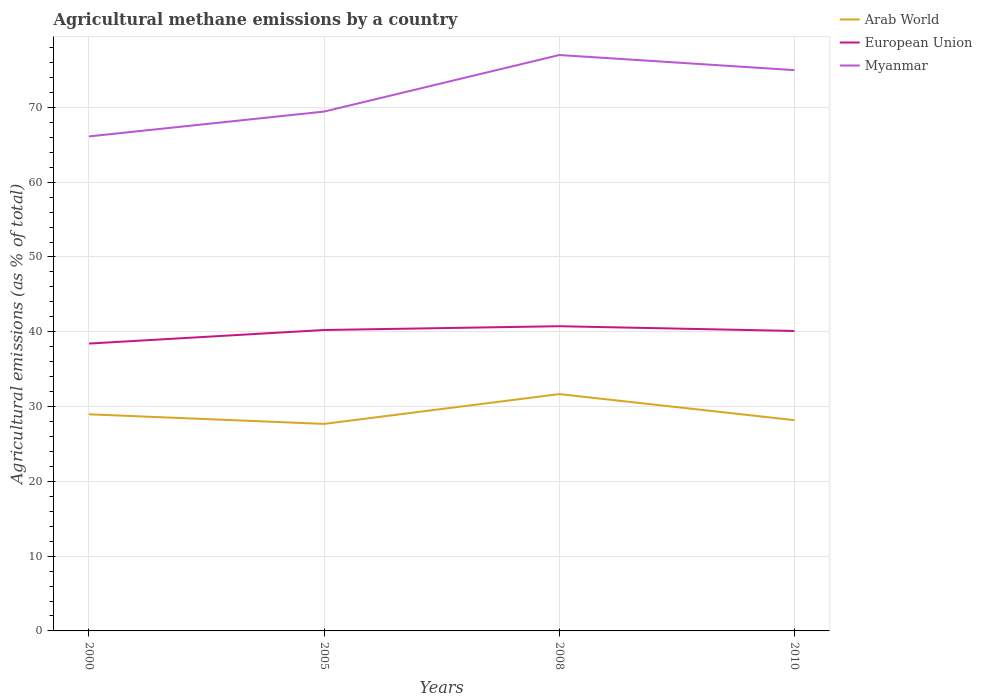How many different coloured lines are there?
Provide a succinct answer. 3. Is the number of lines equal to the number of legend labels?
Your answer should be compact. Yes. Across all years, what is the maximum amount of agricultural methane emitted in Myanmar?
Your response must be concise. 66.12. In which year was the amount of agricultural methane emitted in European Union maximum?
Offer a very short reply. 2000. What is the total amount of agricultural methane emitted in European Union in the graph?
Your response must be concise. -0.51. What is the difference between the highest and the second highest amount of agricultural methane emitted in Arab World?
Provide a short and direct response. 3.99. What is the difference between the highest and the lowest amount of agricultural methane emitted in Arab World?
Your answer should be very brief. 1. What is the difference between two consecutive major ticks on the Y-axis?
Your answer should be compact. 10. Does the graph contain grids?
Offer a very short reply. Yes. How are the legend labels stacked?
Offer a terse response. Vertical. What is the title of the graph?
Provide a succinct answer. Agricultural methane emissions by a country. What is the label or title of the Y-axis?
Ensure brevity in your answer.  Agricultural emissions (as % of total). What is the Agricultural emissions (as % of total) of Arab World in 2000?
Make the answer very short. 28.96. What is the Agricultural emissions (as % of total) in European Union in 2000?
Keep it short and to the point. 38.42. What is the Agricultural emissions (as % of total) of Myanmar in 2000?
Your answer should be compact. 66.12. What is the Agricultural emissions (as % of total) in Arab World in 2005?
Offer a very short reply. 27.68. What is the Agricultural emissions (as % of total) of European Union in 2005?
Keep it short and to the point. 40.24. What is the Agricultural emissions (as % of total) in Myanmar in 2005?
Offer a very short reply. 69.44. What is the Agricultural emissions (as % of total) in Arab World in 2008?
Offer a very short reply. 31.67. What is the Agricultural emissions (as % of total) of European Union in 2008?
Offer a terse response. 40.74. What is the Agricultural emissions (as % of total) in Myanmar in 2008?
Give a very brief answer. 77. What is the Agricultural emissions (as % of total) of Arab World in 2010?
Offer a terse response. 28.18. What is the Agricultural emissions (as % of total) of European Union in 2010?
Your response must be concise. 40.11. What is the Agricultural emissions (as % of total) in Myanmar in 2010?
Provide a succinct answer. 74.98. Across all years, what is the maximum Agricultural emissions (as % of total) of Arab World?
Provide a short and direct response. 31.67. Across all years, what is the maximum Agricultural emissions (as % of total) in European Union?
Give a very brief answer. 40.74. Across all years, what is the maximum Agricultural emissions (as % of total) of Myanmar?
Offer a very short reply. 77. Across all years, what is the minimum Agricultural emissions (as % of total) in Arab World?
Your response must be concise. 27.68. Across all years, what is the minimum Agricultural emissions (as % of total) of European Union?
Ensure brevity in your answer.  38.42. Across all years, what is the minimum Agricultural emissions (as % of total) of Myanmar?
Keep it short and to the point. 66.12. What is the total Agricultural emissions (as % of total) in Arab World in the graph?
Keep it short and to the point. 116.49. What is the total Agricultural emissions (as % of total) in European Union in the graph?
Your answer should be compact. 159.5. What is the total Agricultural emissions (as % of total) in Myanmar in the graph?
Your response must be concise. 287.54. What is the difference between the Agricultural emissions (as % of total) of Arab World in 2000 and that in 2005?
Give a very brief answer. 1.28. What is the difference between the Agricultural emissions (as % of total) of European Union in 2000 and that in 2005?
Offer a very short reply. -1.81. What is the difference between the Agricultural emissions (as % of total) in Myanmar in 2000 and that in 2005?
Your answer should be very brief. -3.32. What is the difference between the Agricultural emissions (as % of total) in Arab World in 2000 and that in 2008?
Your answer should be compact. -2.7. What is the difference between the Agricultural emissions (as % of total) in European Union in 2000 and that in 2008?
Make the answer very short. -2.32. What is the difference between the Agricultural emissions (as % of total) in Myanmar in 2000 and that in 2008?
Your answer should be very brief. -10.88. What is the difference between the Agricultural emissions (as % of total) of Arab World in 2000 and that in 2010?
Offer a terse response. 0.79. What is the difference between the Agricultural emissions (as % of total) of European Union in 2000 and that in 2010?
Keep it short and to the point. -1.68. What is the difference between the Agricultural emissions (as % of total) in Myanmar in 2000 and that in 2010?
Your answer should be very brief. -8.86. What is the difference between the Agricultural emissions (as % of total) of Arab World in 2005 and that in 2008?
Provide a short and direct response. -3.99. What is the difference between the Agricultural emissions (as % of total) in European Union in 2005 and that in 2008?
Ensure brevity in your answer.  -0.51. What is the difference between the Agricultural emissions (as % of total) in Myanmar in 2005 and that in 2008?
Provide a succinct answer. -7.56. What is the difference between the Agricultural emissions (as % of total) of Arab World in 2005 and that in 2010?
Give a very brief answer. -0.5. What is the difference between the Agricultural emissions (as % of total) in European Union in 2005 and that in 2010?
Your response must be concise. 0.13. What is the difference between the Agricultural emissions (as % of total) in Myanmar in 2005 and that in 2010?
Ensure brevity in your answer.  -5.54. What is the difference between the Agricultural emissions (as % of total) in Arab World in 2008 and that in 2010?
Ensure brevity in your answer.  3.49. What is the difference between the Agricultural emissions (as % of total) in European Union in 2008 and that in 2010?
Your answer should be very brief. 0.64. What is the difference between the Agricultural emissions (as % of total) in Myanmar in 2008 and that in 2010?
Ensure brevity in your answer.  2.02. What is the difference between the Agricultural emissions (as % of total) of Arab World in 2000 and the Agricultural emissions (as % of total) of European Union in 2005?
Provide a succinct answer. -11.27. What is the difference between the Agricultural emissions (as % of total) in Arab World in 2000 and the Agricultural emissions (as % of total) in Myanmar in 2005?
Provide a succinct answer. -40.48. What is the difference between the Agricultural emissions (as % of total) of European Union in 2000 and the Agricultural emissions (as % of total) of Myanmar in 2005?
Offer a very short reply. -31.02. What is the difference between the Agricultural emissions (as % of total) of Arab World in 2000 and the Agricultural emissions (as % of total) of European Union in 2008?
Give a very brief answer. -11.78. What is the difference between the Agricultural emissions (as % of total) in Arab World in 2000 and the Agricultural emissions (as % of total) in Myanmar in 2008?
Give a very brief answer. -48.04. What is the difference between the Agricultural emissions (as % of total) in European Union in 2000 and the Agricultural emissions (as % of total) in Myanmar in 2008?
Offer a terse response. -38.58. What is the difference between the Agricultural emissions (as % of total) in Arab World in 2000 and the Agricultural emissions (as % of total) in European Union in 2010?
Give a very brief answer. -11.14. What is the difference between the Agricultural emissions (as % of total) in Arab World in 2000 and the Agricultural emissions (as % of total) in Myanmar in 2010?
Keep it short and to the point. -46.02. What is the difference between the Agricultural emissions (as % of total) in European Union in 2000 and the Agricultural emissions (as % of total) in Myanmar in 2010?
Your answer should be very brief. -36.56. What is the difference between the Agricultural emissions (as % of total) in Arab World in 2005 and the Agricultural emissions (as % of total) in European Union in 2008?
Your answer should be very brief. -13.06. What is the difference between the Agricultural emissions (as % of total) of Arab World in 2005 and the Agricultural emissions (as % of total) of Myanmar in 2008?
Offer a terse response. -49.32. What is the difference between the Agricultural emissions (as % of total) in European Union in 2005 and the Agricultural emissions (as % of total) in Myanmar in 2008?
Provide a short and direct response. -36.77. What is the difference between the Agricultural emissions (as % of total) in Arab World in 2005 and the Agricultural emissions (as % of total) in European Union in 2010?
Keep it short and to the point. -12.43. What is the difference between the Agricultural emissions (as % of total) in Arab World in 2005 and the Agricultural emissions (as % of total) in Myanmar in 2010?
Provide a short and direct response. -47.3. What is the difference between the Agricultural emissions (as % of total) of European Union in 2005 and the Agricultural emissions (as % of total) of Myanmar in 2010?
Provide a short and direct response. -34.75. What is the difference between the Agricultural emissions (as % of total) in Arab World in 2008 and the Agricultural emissions (as % of total) in European Union in 2010?
Give a very brief answer. -8.44. What is the difference between the Agricultural emissions (as % of total) of Arab World in 2008 and the Agricultural emissions (as % of total) of Myanmar in 2010?
Give a very brief answer. -43.32. What is the difference between the Agricultural emissions (as % of total) of European Union in 2008 and the Agricultural emissions (as % of total) of Myanmar in 2010?
Your answer should be compact. -34.24. What is the average Agricultural emissions (as % of total) in Arab World per year?
Offer a very short reply. 29.12. What is the average Agricultural emissions (as % of total) in European Union per year?
Provide a short and direct response. 39.88. What is the average Agricultural emissions (as % of total) of Myanmar per year?
Provide a short and direct response. 71.89. In the year 2000, what is the difference between the Agricultural emissions (as % of total) in Arab World and Agricultural emissions (as % of total) in European Union?
Ensure brevity in your answer.  -9.46. In the year 2000, what is the difference between the Agricultural emissions (as % of total) of Arab World and Agricultural emissions (as % of total) of Myanmar?
Ensure brevity in your answer.  -37.16. In the year 2000, what is the difference between the Agricultural emissions (as % of total) in European Union and Agricultural emissions (as % of total) in Myanmar?
Your answer should be compact. -27.7. In the year 2005, what is the difference between the Agricultural emissions (as % of total) in Arab World and Agricultural emissions (as % of total) in European Union?
Keep it short and to the point. -12.55. In the year 2005, what is the difference between the Agricultural emissions (as % of total) of Arab World and Agricultural emissions (as % of total) of Myanmar?
Provide a short and direct response. -41.76. In the year 2005, what is the difference between the Agricultural emissions (as % of total) in European Union and Agricultural emissions (as % of total) in Myanmar?
Offer a very short reply. -29.21. In the year 2008, what is the difference between the Agricultural emissions (as % of total) of Arab World and Agricultural emissions (as % of total) of European Union?
Offer a terse response. -9.07. In the year 2008, what is the difference between the Agricultural emissions (as % of total) in Arab World and Agricultural emissions (as % of total) in Myanmar?
Make the answer very short. -45.34. In the year 2008, what is the difference between the Agricultural emissions (as % of total) in European Union and Agricultural emissions (as % of total) in Myanmar?
Ensure brevity in your answer.  -36.26. In the year 2010, what is the difference between the Agricultural emissions (as % of total) of Arab World and Agricultural emissions (as % of total) of European Union?
Your answer should be compact. -11.93. In the year 2010, what is the difference between the Agricultural emissions (as % of total) in Arab World and Agricultural emissions (as % of total) in Myanmar?
Your answer should be compact. -46.81. In the year 2010, what is the difference between the Agricultural emissions (as % of total) of European Union and Agricultural emissions (as % of total) of Myanmar?
Provide a succinct answer. -34.88. What is the ratio of the Agricultural emissions (as % of total) of Arab World in 2000 to that in 2005?
Your response must be concise. 1.05. What is the ratio of the Agricultural emissions (as % of total) in European Union in 2000 to that in 2005?
Provide a succinct answer. 0.95. What is the ratio of the Agricultural emissions (as % of total) in Myanmar in 2000 to that in 2005?
Your answer should be compact. 0.95. What is the ratio of the Agricultural emissions (as % of total) of Arab World in 2000 to that in 2008?
Offer a very short reply. 0.91. What is the ratio of the Agricultural emissions (as % of total) of European Union in 2000 to that in 2008?
Ensure brevity in your answer.  0.94. What is the ratio of the Agricultural emissions (as % of total) in Myanmar in 2000 to that in 2008?
Ensure brevity in your answer.  0.86. What is the ratio of the Agricultural emissions (as % of total) in Arab World in 2000 to that in 2010?
Ensure brevity in your answer.  1.03. What is the ratio of the Agricultural emissions (as % of total) in European Union in 2000 to that in 2010?
Make the answer very short. 0.96. What is the ratio of the Agricultural emissions (as % of total) of Myanmar in 2000 to that in 2010?
Ensure brevity in your answer.  0.88. What is the ratio of the Agricultural emissions (as % of total) in Arab World in 2005 to that in 2008?
Offer a terse response. 0.87. What is the ratio of the Agricultural emissions (as % of total) of European Union in 2005 to that in 2008?
Ensure brevity in your answer.  0.99. What is the ratio of the Agricultural emissions (as % of total) of Myanmar in 2005 to that in 2008?
Provide a succinct answer. 0.9. What is the ratio of the Agricultural emissions (as % of total) in Arab World in 2005 to that in 2010?
Provide a short and direct response. 0.98. What is the ratio of the Agricultural emissions (as % of total) of European Union in 2005 to that in 2010?
Give a very brief answer. 1. What is the ratio of the Agricultural emissions (as % of total) of Myanmar in 2005 to that in 2010?
Provide a succinct answer. 0.93. What is the ratio of the Agricultural emissions (as % of total) in Arab World in 2008 to that in 2010?
Your response must be concise. 1.12. What is the ratio of the Agricultural emissions (as % of total) of European Union in 2008 to that in 2010?
Make the answer very short. 1.02. What is the ratio of the Agricultural emissions (as % of total) of Myanmar in 2008 to that in 2010?
Your answer should be compact. 1.03. What is the difference between the highest and the second highest Agricultural emissions (as % of total) in Arab World?
Give a very brief answer. 2.7. What is the difference between the highest and the second highest Agricultural emissions (as % of total) in European Union?
Offer a very short reply. 0.51. What is the difference between the highest and the second highest Agricultural emissions (as % of total) of Myanmar?
Offer a very short reply. 2.02. What is the difference between the highest and the lowest Agricultural emissions (as % of total) in Arab World?
Keep it short and to the point. 3.99. What is the difference between the highest and the lowest Agricultural emissions (as % of total) in European Union?
Keep it short and to the point. 2.32. What is the difference between the highest and the lowest Agricultural emissions (as % of total) of Myanmar?
Make the answer very short. 10.88. 